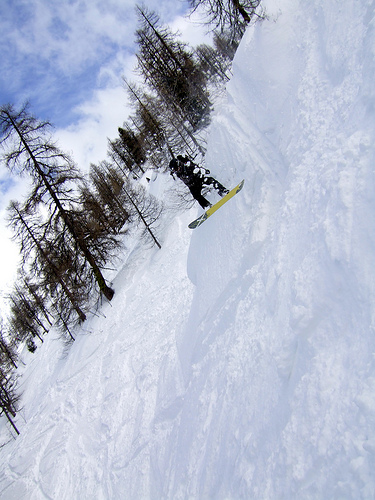<image>
Is the tree behind the snowboarder? Yes. From this viewpoint, the tree is positioned behind the snowboarder, with the snowboarder partially or fully occluding the tree. 